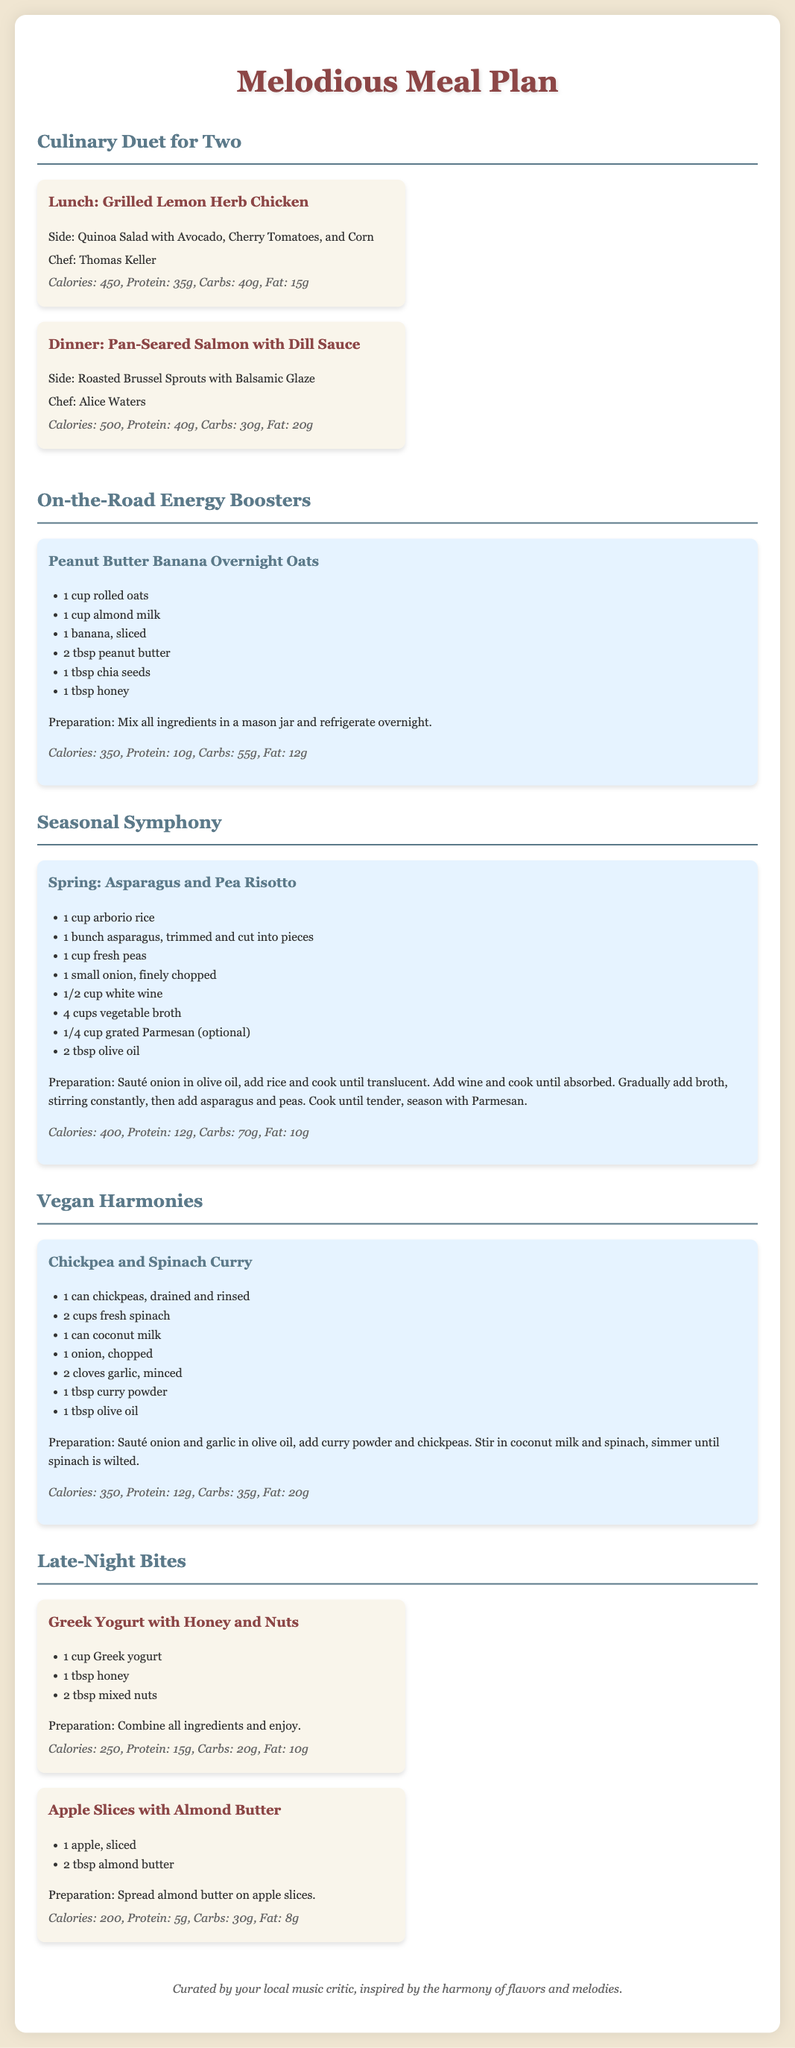What is the title of the document? The title of the document is indicated at the top and says "Melodious Meal Plan".
Answer: Melodious Meal Plan Who is the chef for the Pan-Seared Salmon with Dill Sauce? The chef's name is provided in the meal description, corresponding to the dish, which is Alice Waters.
Answer: Alice Waters How many calories are in the Grilled Lemon Herb Chicken? The calorie information for each meal is given, and for this dish, it is 450 calories.
Answer: 450 What are the ingredients in the Peanut Butter Banana Overnight Oats? The document lists the ingredients specifically for this recipe, including rolled oats, almond milk, banana, peanut butter, chia seeds, and honey.
Answer: 1 cup rolled oats, 1 cup almond milk, 1 banana, 2 tbsp peanut butter, 1 tbsp chia seeds, 1 tbsp honey Which seasonal ingredients are used in the Spring recipe? The Spring recipe features asparagus and peas, which are indicated in the dish description.
Answer: Asparagus and peas What is a recommended side dish for the Chickpea and Spinach Curry? The meal plan contains only the recipe for the Chickpea and Spinach Curry without any specific side dishes mentioned.
Answer: N/A What is the calorie count for Greek Yogurt with Honey and Nuts? The document specifies the calorie count and nutritional information, which states it is 250 calories.
Answer: 250 How many grams of protein are in the Apple Slices with Almond Butter? The nutritional information states that this dish contains 5 grams of protein.
Answer: 5 How many recipes are featured in the Vegan Harmonies section? The document lists only one recipe within the Vegan Harmonies section.
Answer: 1 